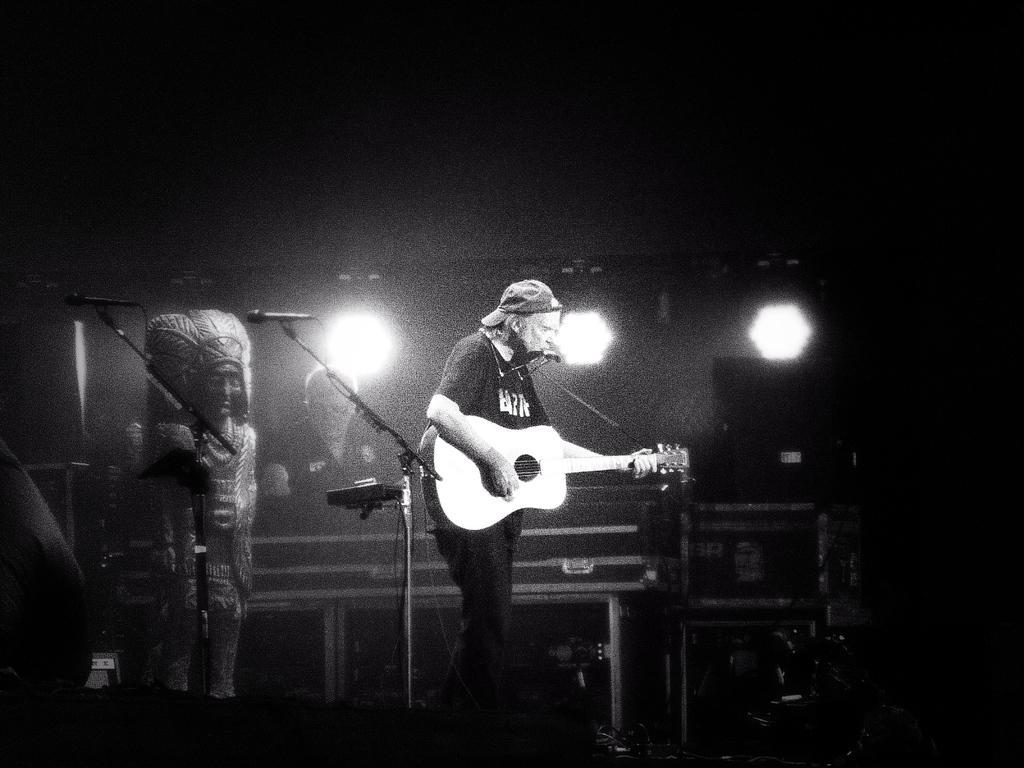Could you give a brief overview of what you see in this image? In this image, In the middle there is a man standing and he is holding a music instrument which is in white color, He is singing in a microphone, There are some microphones which are in black color, In the background there are some lights which are in white color. 